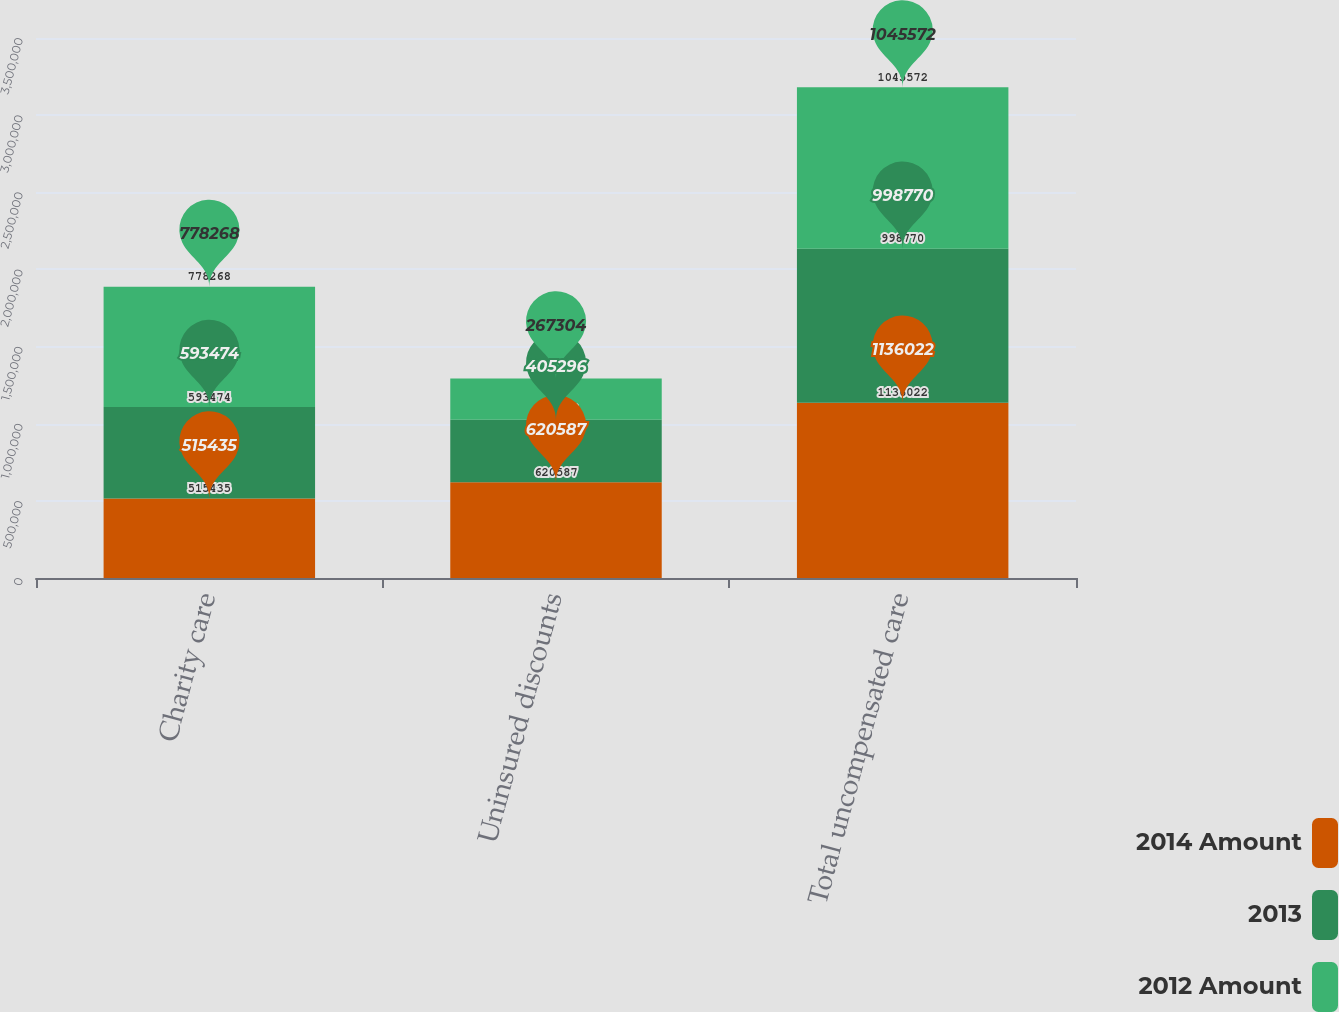Convert chart to OTSL. <chart><loc_0><loc_0><loc_500><loc_500><stacked_bar_chart><ecel><fcel>Charity care<fcel>Uninsured discounts<fcel>Total uncompensated care<nl><fcel>2014 Amount<fcel>515435<fcel>620587<fcel>1.13602e+06<nl><fcel>2013<fcel>593474<fcel>405296<fcel>998770<nl><fcel>2012 Amount<fcel>778268<fcel>267304<fcel>1.04557e+06<nl></chart> 